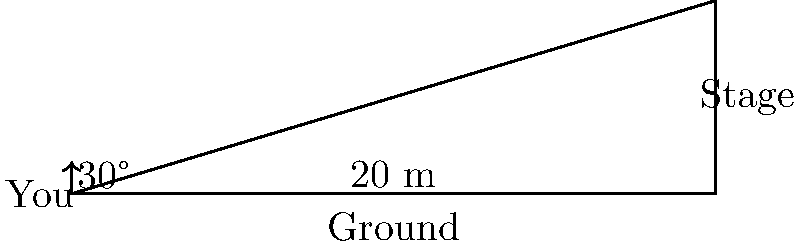At a TV On The Radio concert, you're standing 20 meters away from the stage. The angle of elevation from your eye level to the top of the stage is 30°. Calculate the height of the stage. Let's approach this step-by-step:

1) We can use the tangent function to solve this problem. The tangent of an angle in a right triangle is the ratio of the opposite side to the adjacent side.

2) In this case:
   - The adjacent side is the distance from you to the stage (20 meters)
   - The opposite side is the height of the stage (what we're trying to find)
   - The angle is 30°

3) Let's call the height of the stage $h$. We can write the equation:

   $$\tan(30°) = \frac{h}{20}$$

4) We know that $\tan(30°) = \frac{1}{\sqrt{3}}$, so we can rewrite the equation:

   $$\frac{1}{\sqrt{3}} = \frac{h}{20}$$

5) To solve for $h$, we multiply both sides by 20:

   $$\frac{20}{\sqrt{3}} = h$$

6) Simplifying:

   $$h = 20 \cdot \frac{1}{\sqrt{3}} \approx 11.55$$

Therefore, the height of the stage is approximately 11.55 meters.
Answer: 11.55 meters 